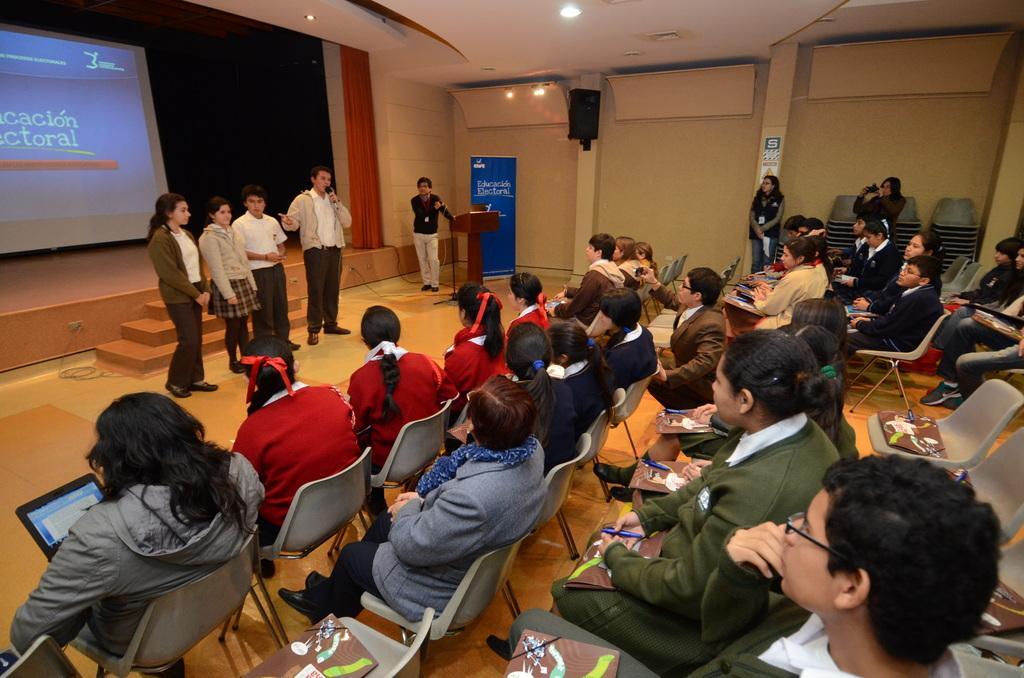In one or two sentences, can you explain what this image depicts? In this picture we can see a group of people,some people are sitting on chairs,some people are standing,here we can see a podium and in the background we can see a wall,roof. 